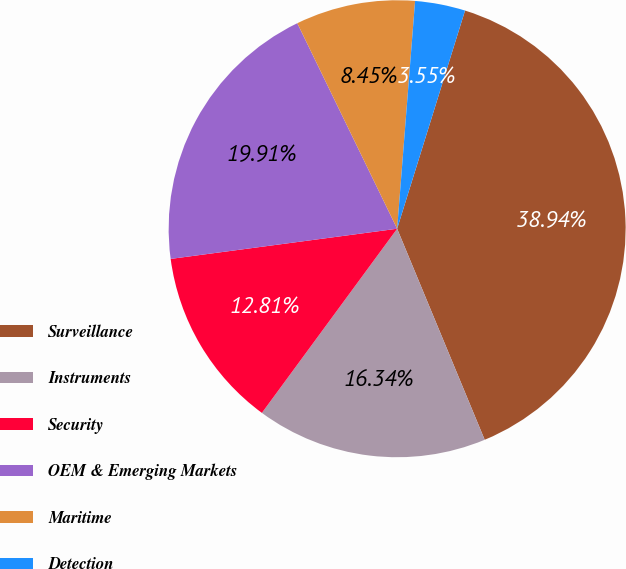Convert chart to OTSL. <chart><loc_0><loc_0><loc_500><loc_500><pie_chart><fcel>Surveillance<fcel>Instruments<fcel>Security<fcel>OEM & Emerging Markets<fcel>Maritime<fcel>Detection<nl><fcel>38.94%<fcel>16.34%<fcel>12.81%<fcel>19.91%<fcel>8.45%<fcel>3.55%<nl></chart> 